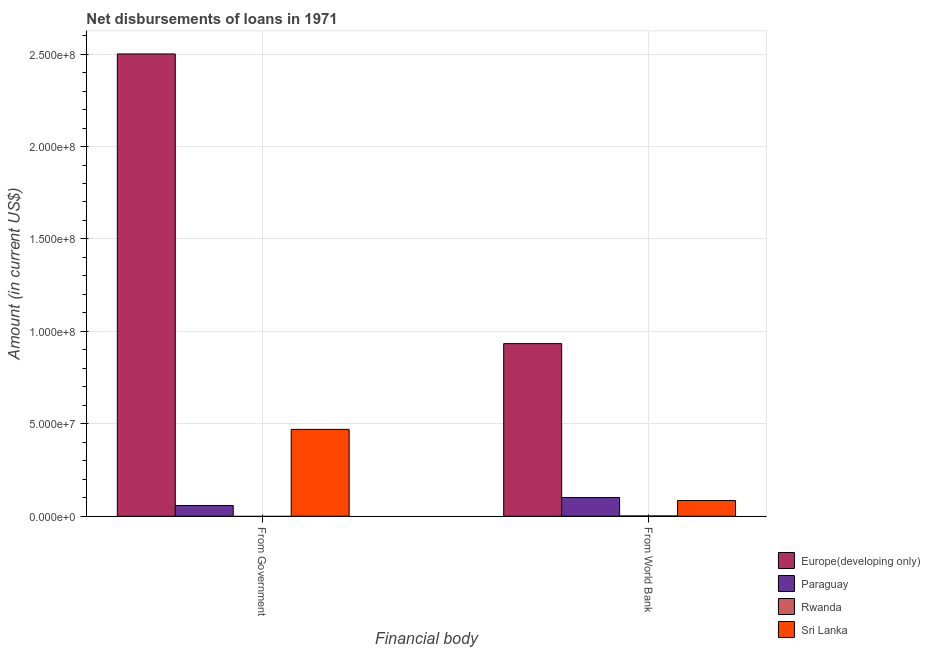How many different coloured bars are there?
Provide a short and direct response. 4. How many groups of bars are there?
Offer a terse response. 2. Are the number of bars per tick equal to the number of legend labels?
Ensure brevity in your answer.  No. How many bars are there on the 2nd tick from the left?
Make the answer very short. 4. How many bars are there on the 2nd tick from the right?
Make the answer very short. 3. What is the label of the 1st group of bars from the left?
Your answer should be compact. From Government. What is the net disbursements of loan from world bank in Paraguay?
Offer a very short reply. 1.01e+07. Across all countries, what is the maximum net disbursements of loan from world bank?
Give a very brief answer. 9.34e+07. Across all countries, what is the minimum net disbursements of loan from world bank?
Ensure brevity in your answer.  1.57e+05. In which country was the net disbursements of loan from world bank maximum?
Give a very brief answer. Europe(developing only). What is the total net disbursements of loan from world bank in the graph?
Offer a terse response. 1.12e+08. What is the difference between the net disbursements of loan from government in Europe(developing only) and that in Paraguay?
Give a very brief answer. 2.44e+08. What is the difference between the net disbursements of loan from government in Rwanda and the net disbursements of loan from world bank in Europe(developing only)?
Provide a short and direct response. -9.34e+07. What is the average net disbursements of loan from government per country?
Provide a short and direct response. 7.57e+07. What is the difference between the net disbursements of loan from government and net disbursements of loan from world bank in Europe(developing only)?
Ensure brevity in your answer.  1.57e+08. What is the ratio of the net disbursements of loan from government in Paraguay to that in Europe(developing only)?
Provide a short and direct response. 0.02. Is the net disbursements of loan from government in Sri Lanka less than that in Paraguay?
Provide a short and direct response. No. In how many countries, is the net disbursements of loan from world bank greater than the average net disbursements of loan from world bank taken over all countries?
Offer a terse response. 1. What is the difference between two consecutive major ticks on the Y-axis?
Provide a short and direct response. 5.00e+07. Does the graph contain any zero values?
Give a very brief answer. Yes. How are the legend labels stacked?
Offer a very short reply. Vertical. What is the title of the graph?
Keep it short and to the point. Net disbursements of loans in 1971. What is the label or title of the X-axis?
Offer a terse response. Financial body. What is the label or title of the Y-axis?
Offer a very short reply. Amount (in current US$). What is the Amount (in current US$) in Europe(developing only) in From Government?
Offer a very short reply. 2.50e+08. What is the Amount (in current US$) of Paraguay in From Government?
Make the answer very short. 5.80e+06. What is the Amount (in current US$) of Sri Lanka in From Government?
Your answer should be compact. 4.70e+07. What is the Amount (in current US$) of Europe(developing only) in From World Bank?
Your response must be concise. 9.34e+07. What is the Amount (in current US$) in Paraguay in From World Bank?
Make the answer very short. 1.01e+07. What is the Amount (in current US$) in Rwanda in From World Bank?
Your answer should be very brief. 1.57e+05. What is the Amount (in current US$) of Sri Lanka in From World Bank?
Give a very brief answer. 8.51e+06. Across all Financial body, what is the maximum Amount (in current US$) in Europe(developing only)?
Your answer should be compact. 2.50e+08. Across all Financial body, what is the maximum Amount (in current US$) in Paraguay?
Keep it short and to the point. 1.01e+07. Across all Financial body, what is the maximum Amount (in current US$) in Rwanda?
Your response must be concise. 1.57e+05. Across all Financial body, what is the maximum Amount (in current US$) in Sri Lanka?
Make the answer very short. 4.70e+07. Across all Financial body, what is the minimum Amount (in current US$) in Europe(developing only)?
Keep it short and to the point. 9.34e+07. Across all Financial body, what is the minimum Amount (in current US$) in Paraguay?
Provide a short and direct response. 5.80e+06. Across all Financial body, what is the minimum Amount (in current US$) in Sri Lanka?
Keep it short and to the point. 8.51e+06. What is the total Amount (in current US$) in Europe(developing only) in the graph?
Offer a terse response. 3.43e+08. What is the total Amount (in current US$) in Paraguay in the graph?
Your response must be concise. 1.59e+07. What is the total Amount (in current US$) in Rwanda in the graph?
Provide a short and direct response. 1.57e+05. What is the total Amount (in current US$) of Sri Lanka in the graph?
Offer a terse response. 5.55e+07. What is the difference between the Amount (in current US$) of Europe(developing only) in From Government and that in From World Bank?
Make the answer very short. 1.57e+08. What is the difference between the Amount (in current US$) in Paraguay in From Government and that in From World Bank?
Ensure brevity in your answer.  -4.34e+06. What is the difference between the Amount (in current US$) in Sri Lanka in From Government and that in From World Bank?
Ensure brevity in your answer.  3.85e+07. What is the difference between the Amount (in current US$) in Europe(developing only) in From Government and the Amount (in current US$) in Paraguay in From World Bank?
Offer a terse response. 2.40e+08. What is the difference between the Amount (in current US$) of Europe(developing only) in From Government and the Amount (in current US$) of Rwanda in From World Bank?
Make the answer very short. 2.50e+08. What is the difference between the Amount (in current US$) of Europe(developing only) in From Government and the Amount (in current US$) of Sri Lanka in From World Bank?
Keep it short and to the point. 2.42e+08. What is the difference between the Amount (in current US$) of Paraguay in From Government and the Amount (in current US$) of Rwanda in From World Bank?
Your answer should be compact. 5.64e+06. What is the difference between the Amount (in current US$) of Paraguay in From Government and the Amount (in current US$) of Sri Lanka in From World Bank?
Offer a terse response. -2.71e+06. What is the average Amount (in current US$) of Europe(developing only) per Financial body?
Your answer should be very brief. 1.72e+08. What is the average Amount (in current US$) of Paraguay per Financial body?
Offer a very short reply. 7.97e+06. What is the average Amount (in current US$) in Rwanda per Financial body?
Offer a terse response. 7.85e+04. What is the average Amount (in current US$) in Sri Lanka per Financial body?
Keep it short and to the point. 2.78e+07. What is the difference between the Amount (in current US$) of Europe(developing only) and Amount (in current US$) of Paraguay in From Government?
Your answer should be compact. 2.44e+08. What is the difference between the Amount (in current US$) of Europe(developing only) and Amount (in current US$) of Sri Lanka in From Government?
Your answer should be compact. 2.03e+08. What is the difference between the Amount (in current US$) of Paraguay and Amount (in current US$) of Sri Lanka in From Government?
Your answer should be very brief. -4.12e+07. What is the difference between the Amount (in current US$) of Europe(developing only) and Amount (in current US$) of Paraguay in From World Bank?
Make the answer very short. 8.32e+07. What is the difference between the Amount (in current US$) in Europe(developing only) and Amount (in current US$) in Rwanda in From World Bank?
Make the answer very short. 9.32e+07. What is the difference between the Amount (in current US$) in Europe(developing only) and Amount (in current US$) in Sri Lanka in From World Bank?
Offer a very short reply. 8.49e+07. What is the difference between the Amount (in current US$) of Paraguay and Amount (in current US$) of Rwanda in From World Bank?
Your answer should be compact. 9.98e+06. What is the difference between the Amount (in current US$) in Paraguay and Amount (in current US$) in Sri Lanka in From World Bank?
Your response must be concise. 1.62e+06. What is the difference between the Amount (in current US$) of Rwanda and Amount (in current US$) of Sri Lanka in From World Bank?
Provide a succinct answer. -8.36e+06. What is the ratio of the Amount (in current US$) in Europe(developing only) in From Government to that in From World Bank?
Your answer should be compact. 2.68. What is the ratio of the Amount (in current US$) in Paraguay in From Government to that in From World Bank?
Your answer should be compact. 0.57. What is the ratio of the Amount (in current US$) in Sri Lanka in From Government to that in From World Bank?
Your answer should be compact. 5.52. What is the difference between the highest and the second highest Amount (in current US$) in Europe(developing only)?
Give a very brief answer. 1.57e+08. What is the difference between the highest and the second highest Amount (in current US$) in Paraguay?
Provide a succinct answer. 4.34e+06. What is the difference between the highest and the second highest Amount (in current US$) in Sri Lanka?
Offer a very short reply. 3.85e+07. What is the difference between the highest and the lowest Amount (in current US$) of Europe(developing only)?
Make the answer very short. 1.57e+08. What is the difference between the highest and the lowest Amount (in current US$) in Paraguay?
Ensure brevity in your answer.  4.34e+06. What is the difference between the highest and the lowest Amount (in current US$) of Rwanda?
Provide a short and direct response. 1.57e+05. What is the difference between the highest and the lowest Amount (in current US$) of Sri Lanka?
Provide a succinct answer. 3.85e+07. 